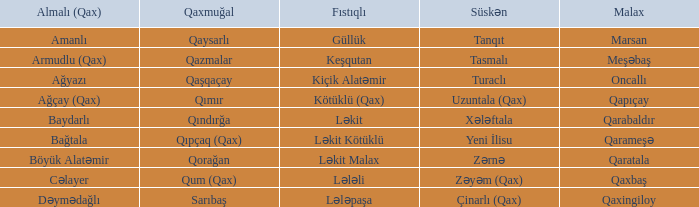What is the Qaxmuğal village with a Fistiqli village keşqutan? Qazmalar. 